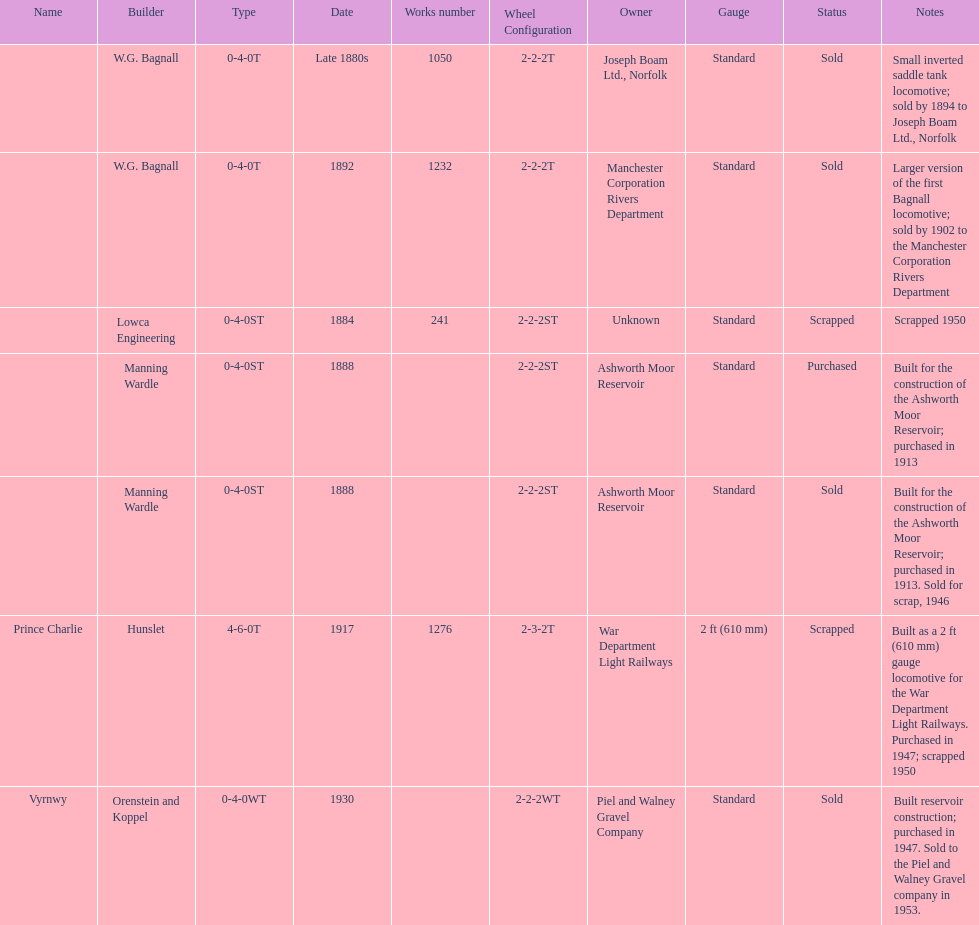How many locomotives were built for the construction of the ashworth moor reservoir? 2. 